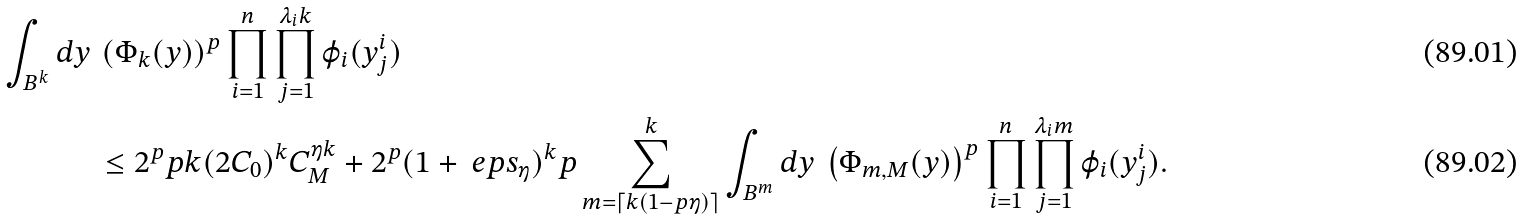Convert formula to latex. <formula><loc_0><loc_0><loc_500><loc_500>\int _ { B ^ { k } } d y \, & \left ( \Phi _ { k } ( y ) \right ) ^ { p } \prod _ { i = 1 } ^ { n } \prod _ { j = 1 } ^ { \lambda _ { i } k } \varphi _ { i } ( y ^ { i } _ { j } ) \\ & \leq 2 ^ { p } p k ( 2 C _ { 0 } ) ^ { k } C _ { M } ^ { \eta k } + 2 ^ { p } ( 1 + \ e p s _ { \eta } ) ^ { k } p \sum _ { m = \lceil k ( 1 - p \eta ) \rceil } ^ { k } \int _ { B ^ { m } } d y \, \left ( \Phi _ { m , M } ( y ) \right ) ^ { p } \prod _ { i = 1 } ^ { n } \prod _ { j = 1 } ^ { \lambda _ { i } m } \varphi _ { i } ( y ^ { i } _ { j } ) .</formula> 